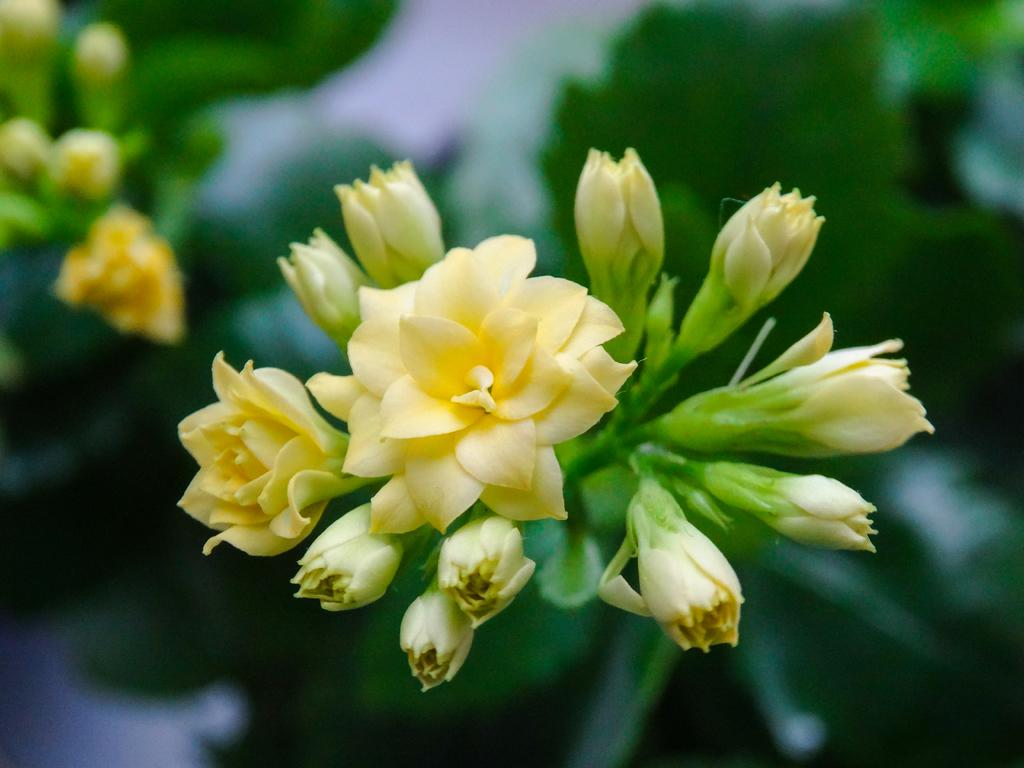What type of flowers can be seen in the image? There are yellow colored flowers in the image. Can you describe the stage of growth of the flowers? There are buds in the image, indicating that some flowers are in the process of blooming. What is the appearance of the background in the image? The background of the image is blurred. What type of drum is visible in the image? There is no drum present in the image. What is the weight of the cub in the image? There is no cub present in the image. 